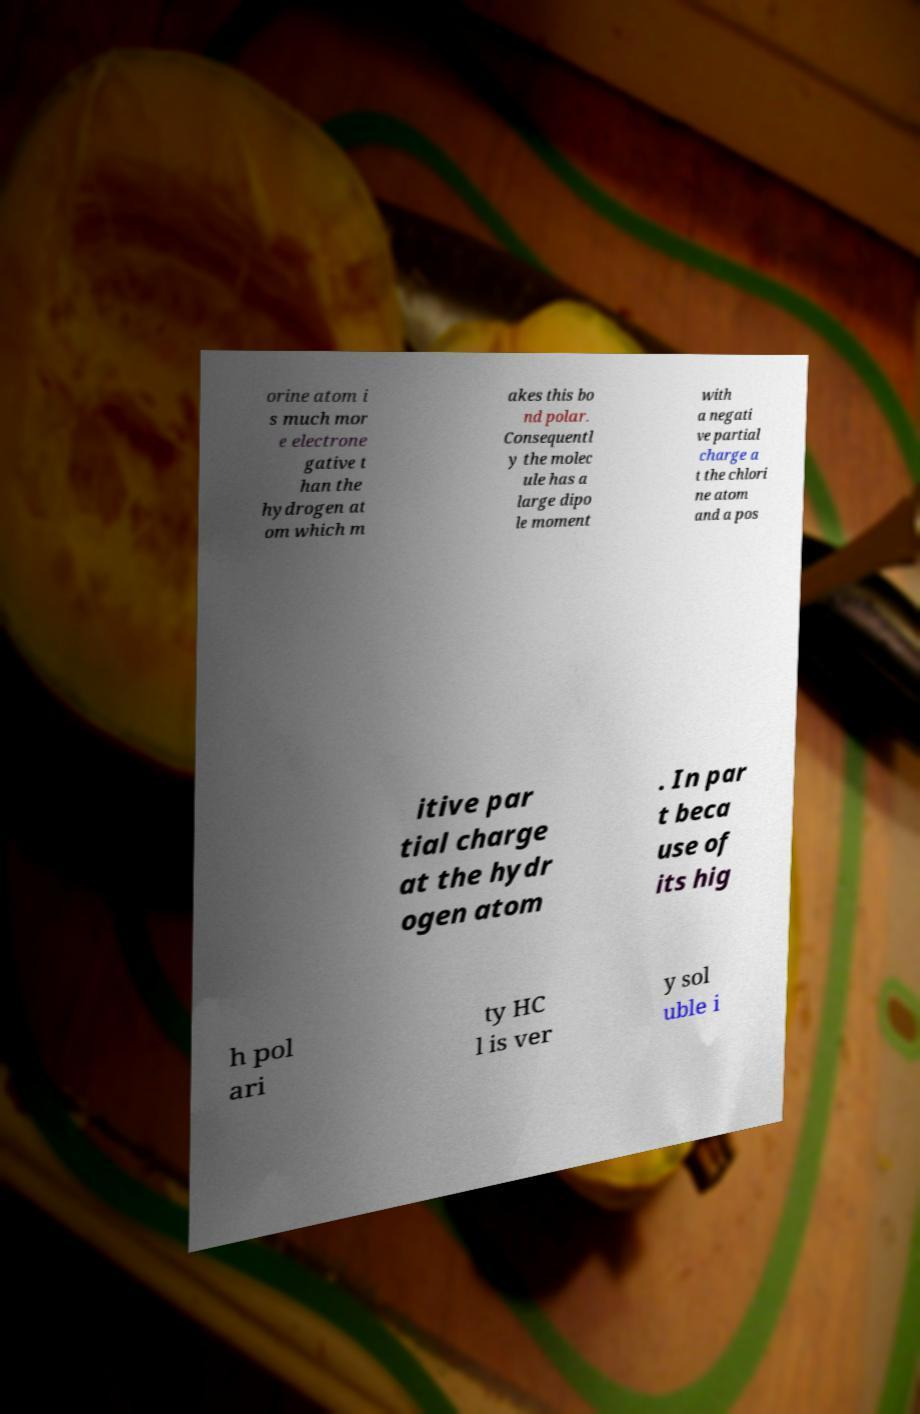Could you extract and type out the text from this image? orine atom i s much mor e electrone gative t han the hydrogen at om which m akes this bo nd polar. Consequentl y the molec ule has a large dipo le moment with a negati ve partial charge a t the chlori ne atom and a pos itive par tial charge at the hydr ogen atom . In par t beca use of its hig h pol ari ty HC l is ver y sol uble i 